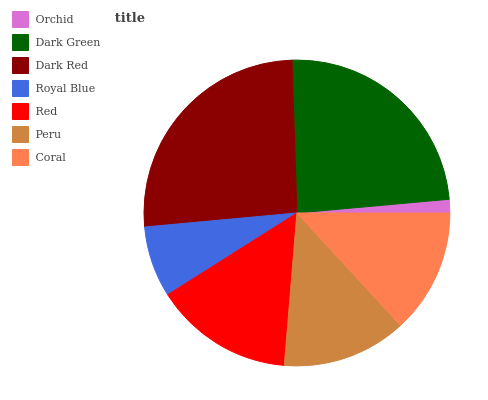Is Orchid the minimum?
Answer yes or no. Yes. Is Dark Red the maximum?
Answer yes or no. Yes. Is Dark Green the minimum?
Answer yes or no. No. Is Dark Green the maximum?
Answer yes or no. No. Is Dark Green greater than Orchid?
Answer yes or no. Yes. Is Orchid less than Dark Green?
Answer yes or no. Yes. Is Orchid greater than Dark Green?
Answer yes or no. No. Is Dark Green less than Orchid?
Answer yes or no. No. Is Coral the high median?
Answer yes or no. Yes. Is Coral the low median?
Answer yes or no. Yes. Is Peru the high median?
Answer yes or no. No. Is Dark Green the low median?
Answer yes or no. No. 